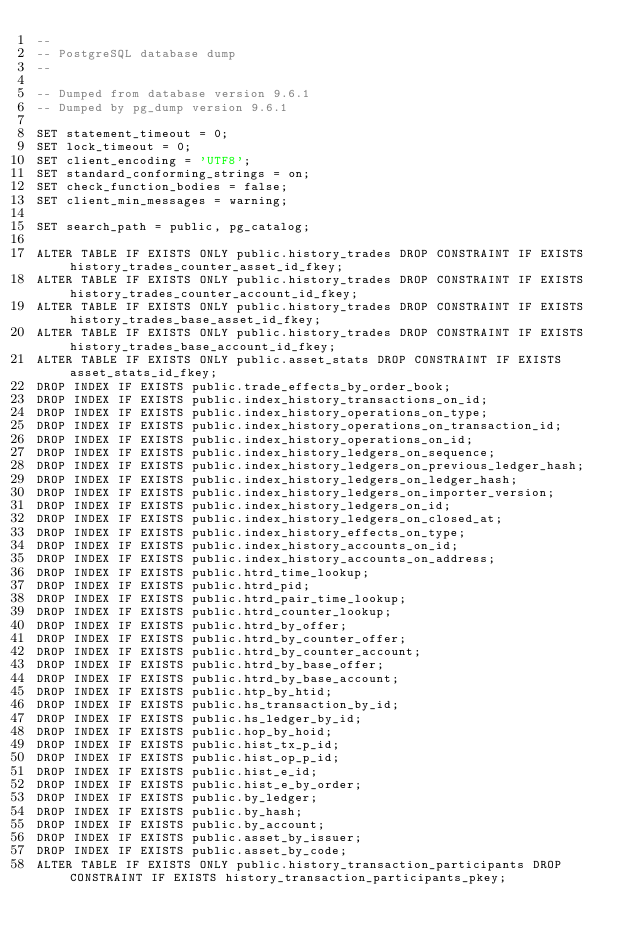<code> <loc_0><loc_0><loc_500><loc_500><_SQL_>--
-- PostgreSQL database dump
--

-- Dumped from database version 9.6.1
-- Dumped by pg_dump version 9.6.1

SET statement_timeout = 0;
SET lock_timeout = 0;
SET client_encoding = 'UTF8';
SET standard_conforming_strings = on;
SET check_function_bodies = false;
SET client_min_messages = warning;

SET search_path = public, pg_catalog;

ALTER TABLE IF EXISTS ONLY public.history_trades DROP CONSTRAINT IF EXISTS history_trades_counter_asset_id_fkey;
ALTER TABLE IF EXISTS ONLY public.history_trades DROP CONSTRAINT IF EXISTS history_trades_counter_account_id_fkey;
ALTER TABLE IF EXISTS ONLY public.history_trades DROP CONSTRAINT IF EXISTS history_trades_base_asset_id_fkey;
ALTER TABLE IF EXISTS ONLY public.history_trades DROP CONSTRAINT IF EXISTS history_trades_base_account_id_fkey;
ALTER TABLE IF EXISTS ONLY public.asset_stats DROP CONSTRAINT IF EXISTS asset_stats_id_fkey;
DROP INDEX IF EXISTS public.trade_effects_by_order_book;
DROP INDEX IF EXISTS public.index_history_transactions_on_id;
DROP INDEX IF EXISTS public.index_history_operations_on_type;
DROP INDEX IF EXISTS public.index_history_operations_on_transaction_id;
DROP INDEX IF EXISTS public.index_history_operations_on_id;
DROP INDEX IF EXISTS public.index_history_ledgers_on_sequence;
DROP INDEX IF EXISTS public.index_history_ledgers_on_previous_ledger_hash;
DROP INDEX IF EXISTS public.index_history_ledgers_on_ledger_hash;
DROP INDEX IF EXISTS public.index_history_ledgers_on_importer_version;
DROP INDEX IF EXISTS public.index_history_ledgers_on_id;
DROP INDEX IF EXISTS public.index_history_ledgers_on_closed_at;
DROP INDEX IF EXISTS public.index_history_effects_on_type;
DROP INDEX IF EXISTS public.index_history_accounts_on_id;
DROP INDEX IF EXISTS public.index_history_accounts_on_address;
DROP INDEX IF EXISTS public.htrd_time_lookup;
DROP INDEX IF EXISTS public.htrd_pid;
DROP INDEX IF EXISTS public.htrd_pair_time_lookup;
DROP INDEX IF EXISTS public.htrd_counter_lookup;
DROP INDEX IF EXISTS public.htrd_by_offer;
DROP INDEX IF EXISTS public.htrd_by_counter_offer;
DROP INDEX IF EXISTS public.htrd_by_counter_account;
DROP INDEX IF EXISTS public.htrd_by_base_offer;
DROP INDEX IF EXISTS public.htrd_by_base_account;
DROP INDEX IF EXISTS public.htp_by_htid;
DROP INDEX IF EXISTS public.hs_transaction_by_id;
DROP INDEX IF EXISTS public.hs_ledger_by_id;
DROP INDEX IF EXISTS public.hop_by_hoid;
DROP INDEX IF EXISTS public.hist_tx_p_id;
DROP INDEX IF EXISTS public.hist_op_p_id;
DROP INDEX IF EXISTS public.hist_e_id;
DROP INDEX IF EXISTS public.hist_e_by_order;
DROP INDEX IF EXISTS public.by_ledger;
DROP INDEX IF EXISTS public.by_hash;
DROP INDEX IF EXISTS public.by_account;
DROP INDEX IF EXISTS public.asset_by_issuer;
DROP INDEX IF EXISTS public.asset_by_code;
ALTER TABLE IF EXISTS ONLY public.history_transaction_participants DROP CONSTRAINT IF EXISTS history_transaction_participants_pkey;</code> 